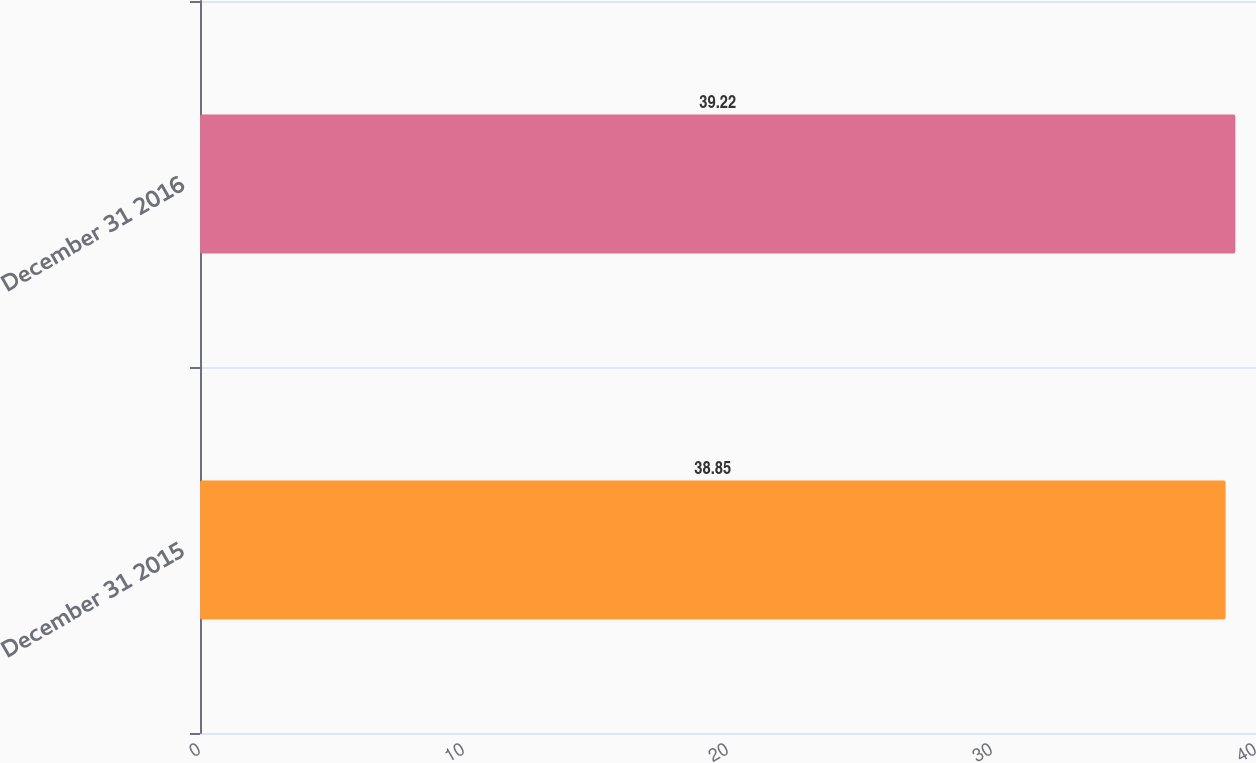Convert chart. <chart><loc_0><loc_0><loc_500><loc_500><bar_chart><fcel>December 31 2015<fcel>December 31 2016<nl><fcel>38.85<fcel>39.22<nl></chart> 